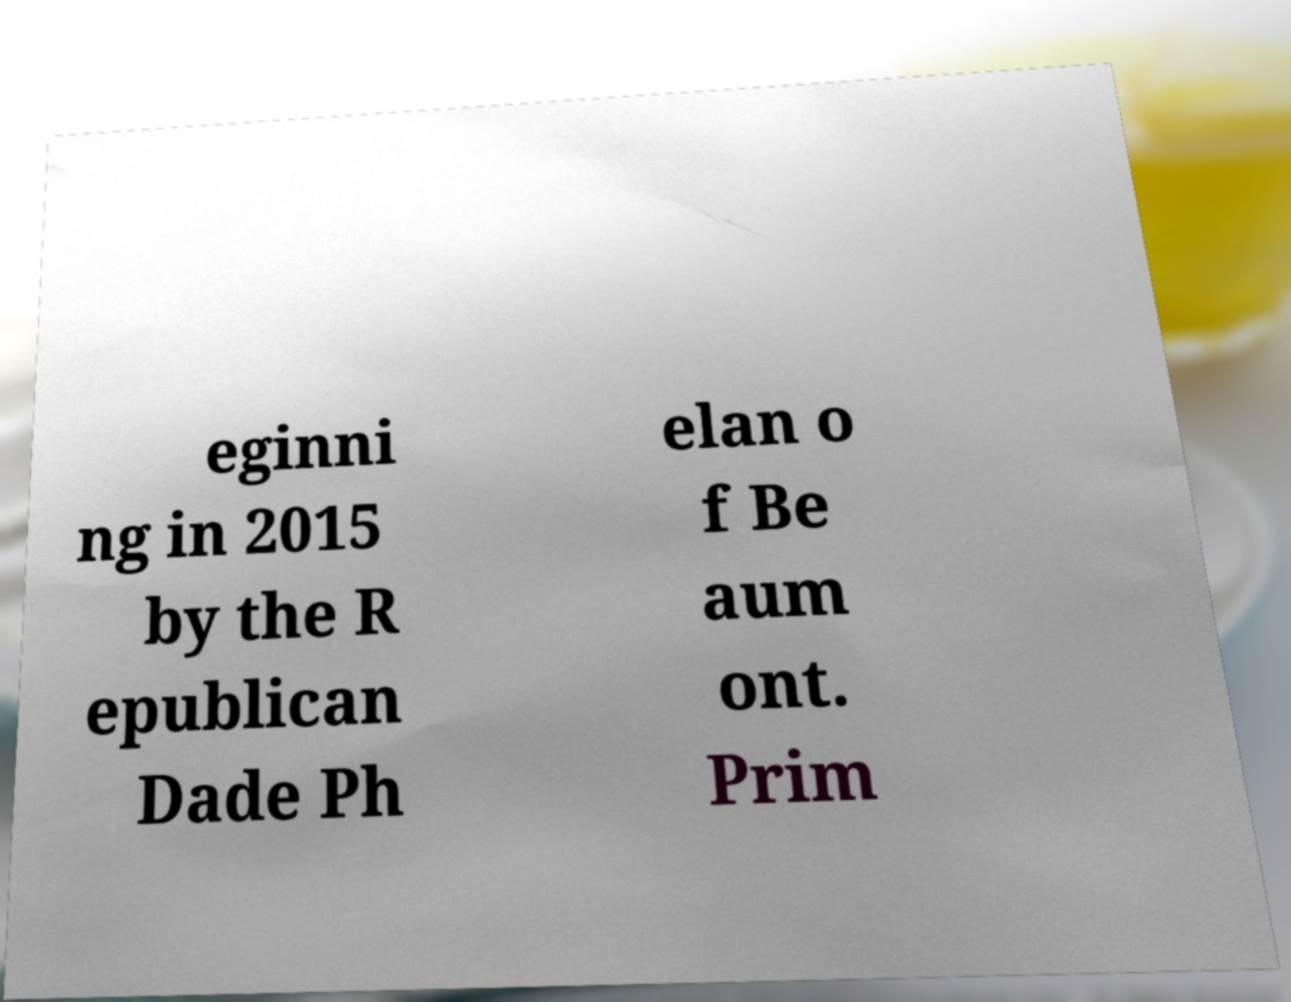For documentation purposes, I need the text within this image transcribed. Could you provide that? eginni ng in 2015 by the R epublican Dade Ph elan o f Be aum ont. Prim 